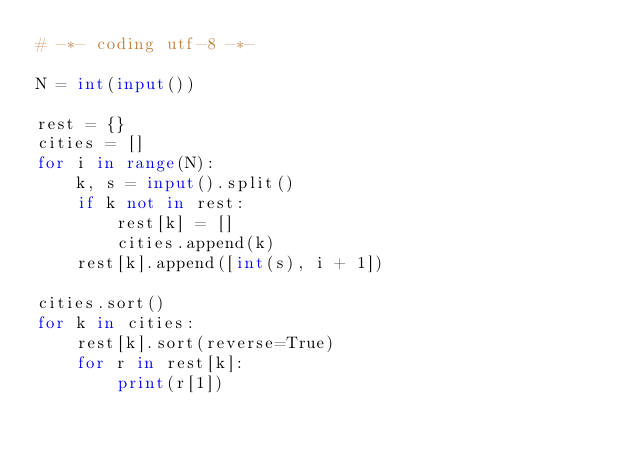<code> <loc_0><loc_0><loc_500><loc_500><_Python_># -*- coding utf-8 -*-

N = int(input())

rest = {}
cities = []
for i in range(N):
    k, s = input().split()
    if k not in rest:
        rest[k] = []
        cities.append(k)
    rest[k].append([int(s), i + 1])

cities.sort()
for k in cities:
    rest[k].sort(reverse=True)
    for r in rest[k]:
        print(r[1])
</code> 